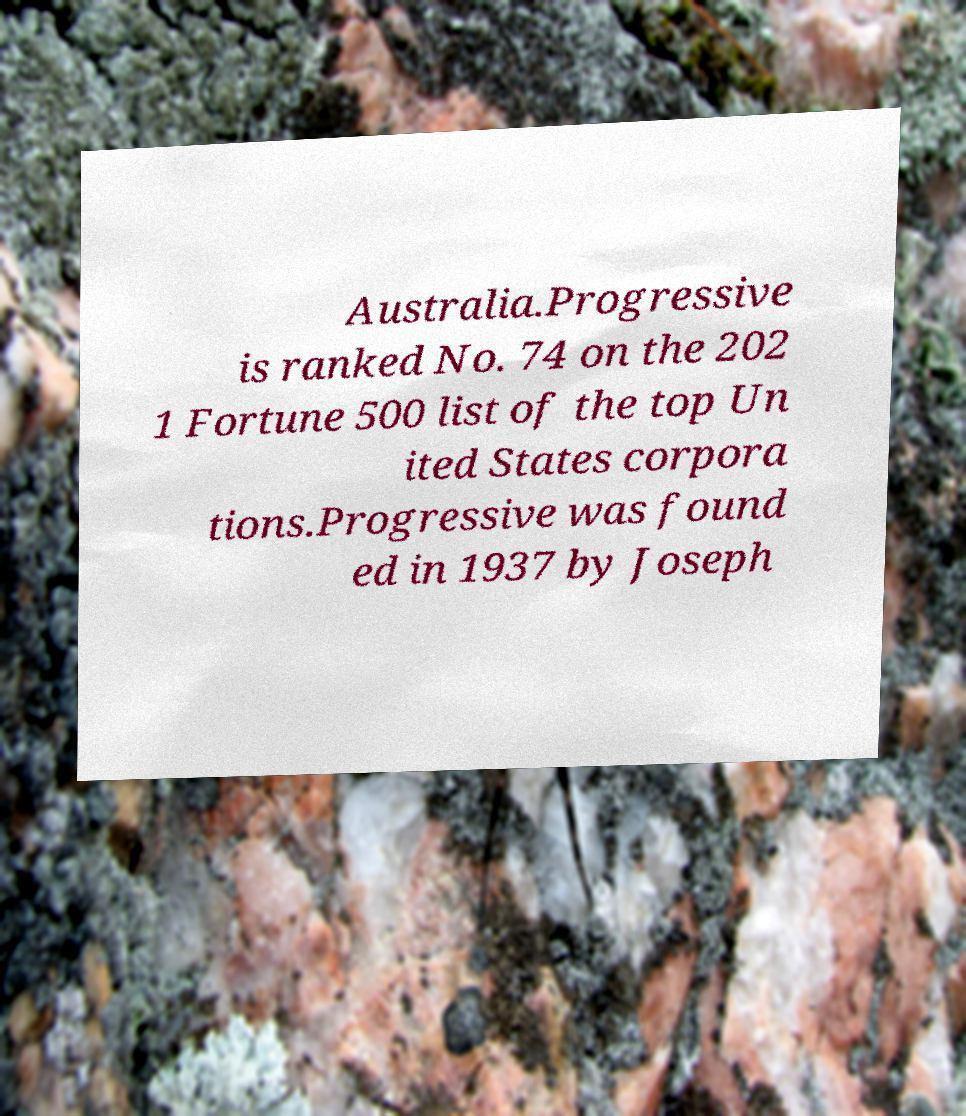I need the written content from this picture converted into text. Can you do that? Australia.Progressive is ranked No. 74 on the 202 1 Fortune 500 list of the top Un ited States corpora tions.Progressive was found ed in 1937 by Joseph 